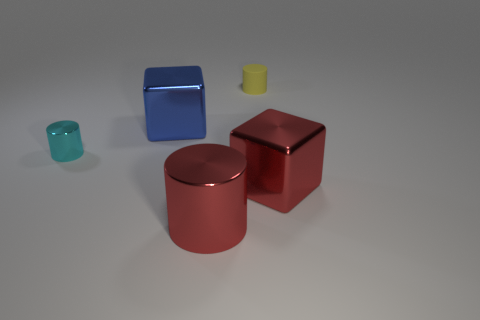Do the big red object that is right of the rubber object and the big cylinder have the same material?
Your answer should be compact. Yes. What number of yellow cylinders are the same size as the blue shiny cube?
Keep it short and to the point. 0. Is the number of big red cubes to the right of the small yellow cylinder greater than the number of big blue blocks left of the cyan metallic thing?
Provide a short and direct response. Yes. Is there another small yellow rubber thing that has the same shape as the tiny matte object?
Give a very brief answer. No. There is a metallic cylinder in front of the cyan cylinder left of the big red cube; what size is it?
Keep it short and to the point. Large. There is a yellow matte thing right of the big cube on the left side of the red object to the left of the red shiny block; what is its shape?
Your response must be concise. Cylinder. What is the size of the cyan cylinder that is the same material as the large blue object?
Ensure brevity in your answer.  Small. Are there more metallic objects than tiny green matte blocks?
Your answer should be very brief. Yes. What material is the block that is the same size as the blue shiny thing?
Your response must be concise. Metal. Do the metallic block that is in front of the blue metallic object and the tiny yellow rubber thing have the same size?
Provide a succinct answer. No. 